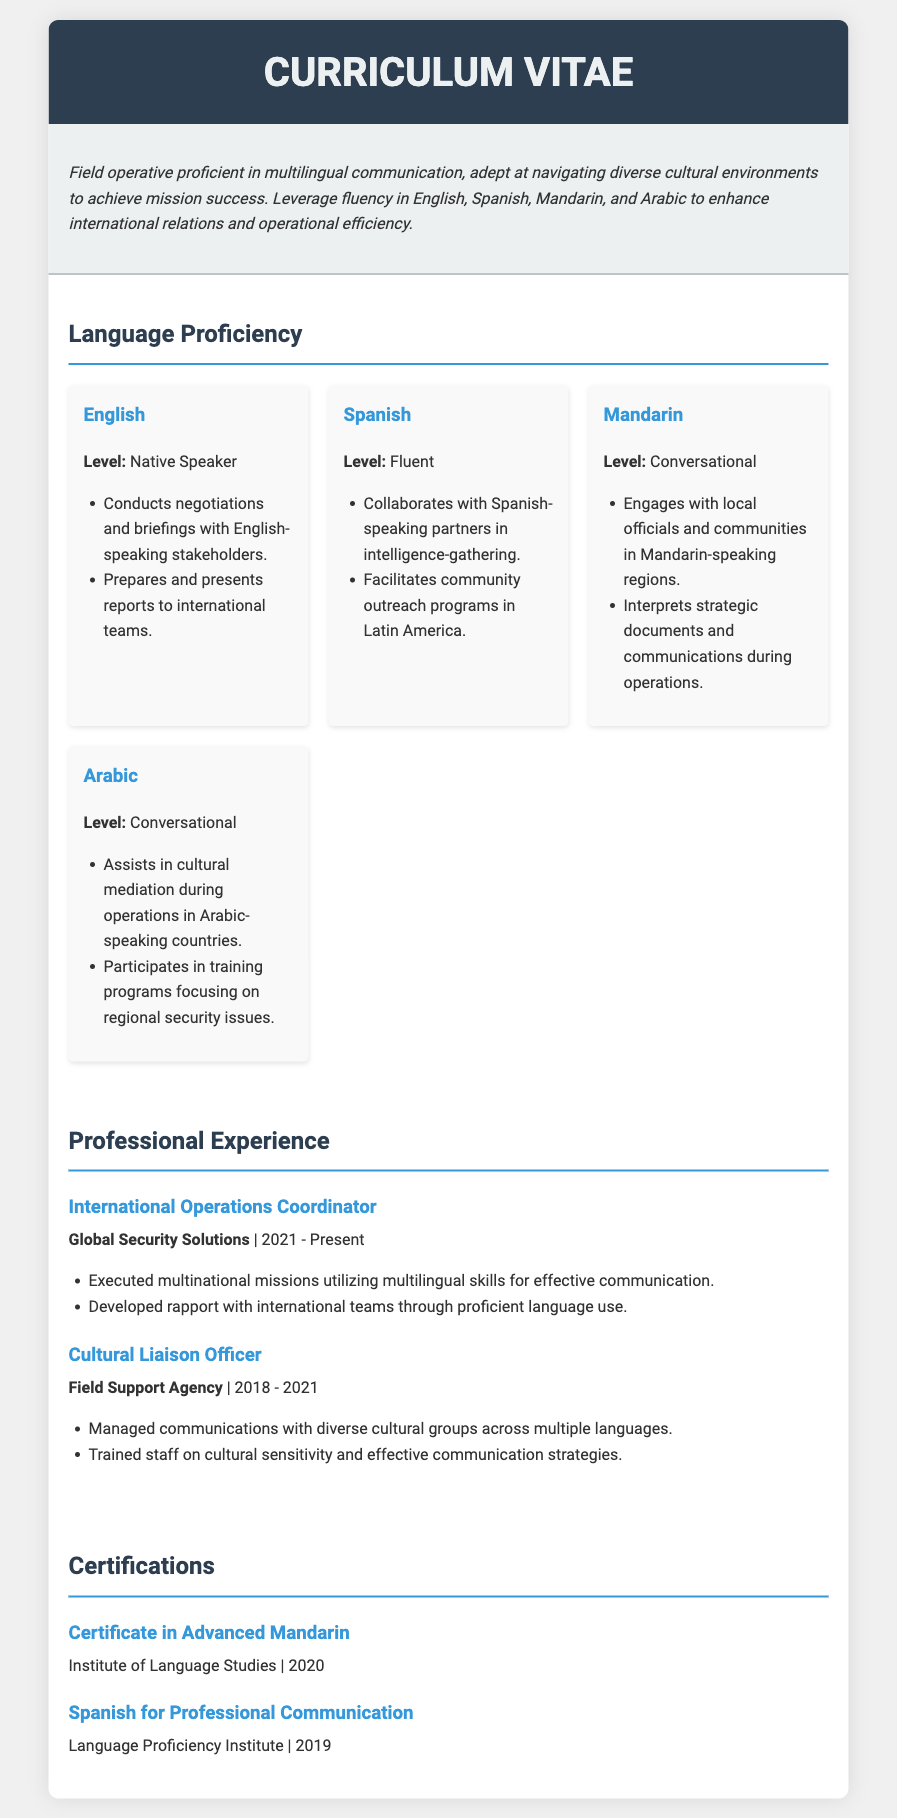What is the native language? The native language is the language that the individual speaks most fluently, which is mentioned in the document as English.
Answer: English What is the proficiency level in Spanish? The proficiency level in Spanish is stated in the document as Fluent.
Answer: Fluent What position did the individual hold from 2021? The position held from 2021 is mentioned as International Operations Coordinator.
Answer: International Operations Coordinator In what year was the Certificate in Advanced Mandarin obtained? The document specifies that the Certificate in Advanced Mandarin was obtained in 2020.
Answer: 2020 What does the individual do in Mandarin-speaking regions? The document indicates the individual engages with local officials and communities in Mandarin-speaking regions.
Answer: Engages with local officials and communities How many languages does the individual have proficiency in? The individual specifies four languages in the document.
Answer: Four What is the role of the Cultural Liaison Officer? The role of the Cultural Liaison Officer includes managing communications with diverse cultural groups.
Answer: Managing communications with diverse cultural groups What organization issued the certification for Spanish for Professional Communication? The organization that issued the certification is mentioned as Language Proficiency Institute.
Answer: Language Proficiency Institute What is the focus of the training programs in Arabic-speaking countries? The focus of the training programs in Arabic-speaking countries is stated as regional security issues.
Answer: Regional security issues 